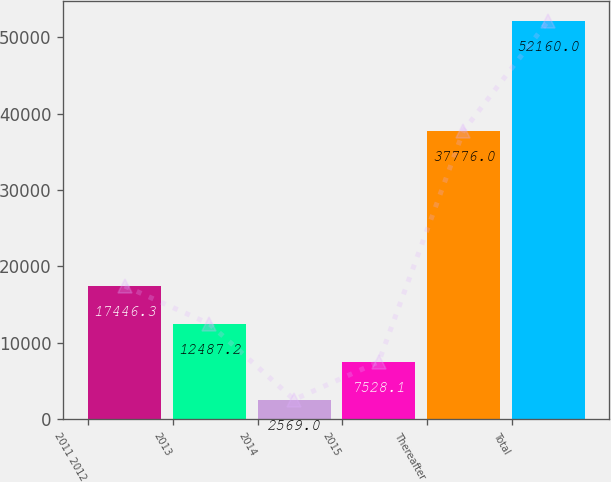<chart> <loc_0><loc_0><loc_500><loc_500><bar_chart><fcel>2011 2012<fcel>2013<fcel>2014<fcel>2015<fcel>Thereafter<fcel>Total<nl><fcel>17446.3<fcel>12487.2<fcel>2569<fcel>7528.1<fcel>37776<fcel>52160<nl></chart> 